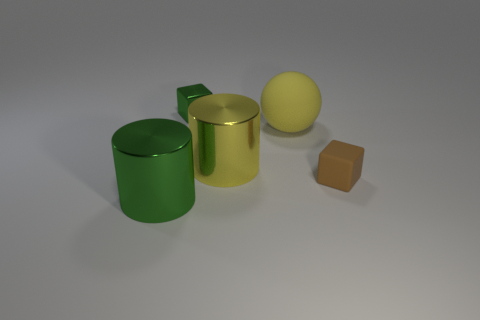Could you speculate on what these objects are used for? The objects might be part of a minimalist aesthetic display or a study of shapes and materials. The cylinder, sphere, and cube could also be considered as models used for educational purposes, perhaps in geometry or art complementary studies. Are there any signs of wear and tear on these objects? No, the objects appear to be pristine with clean, smooth surfaces, and consistent colors, which suggests they are new or well-maintained. The lack of any imperfections adds to the idealized appearance. 